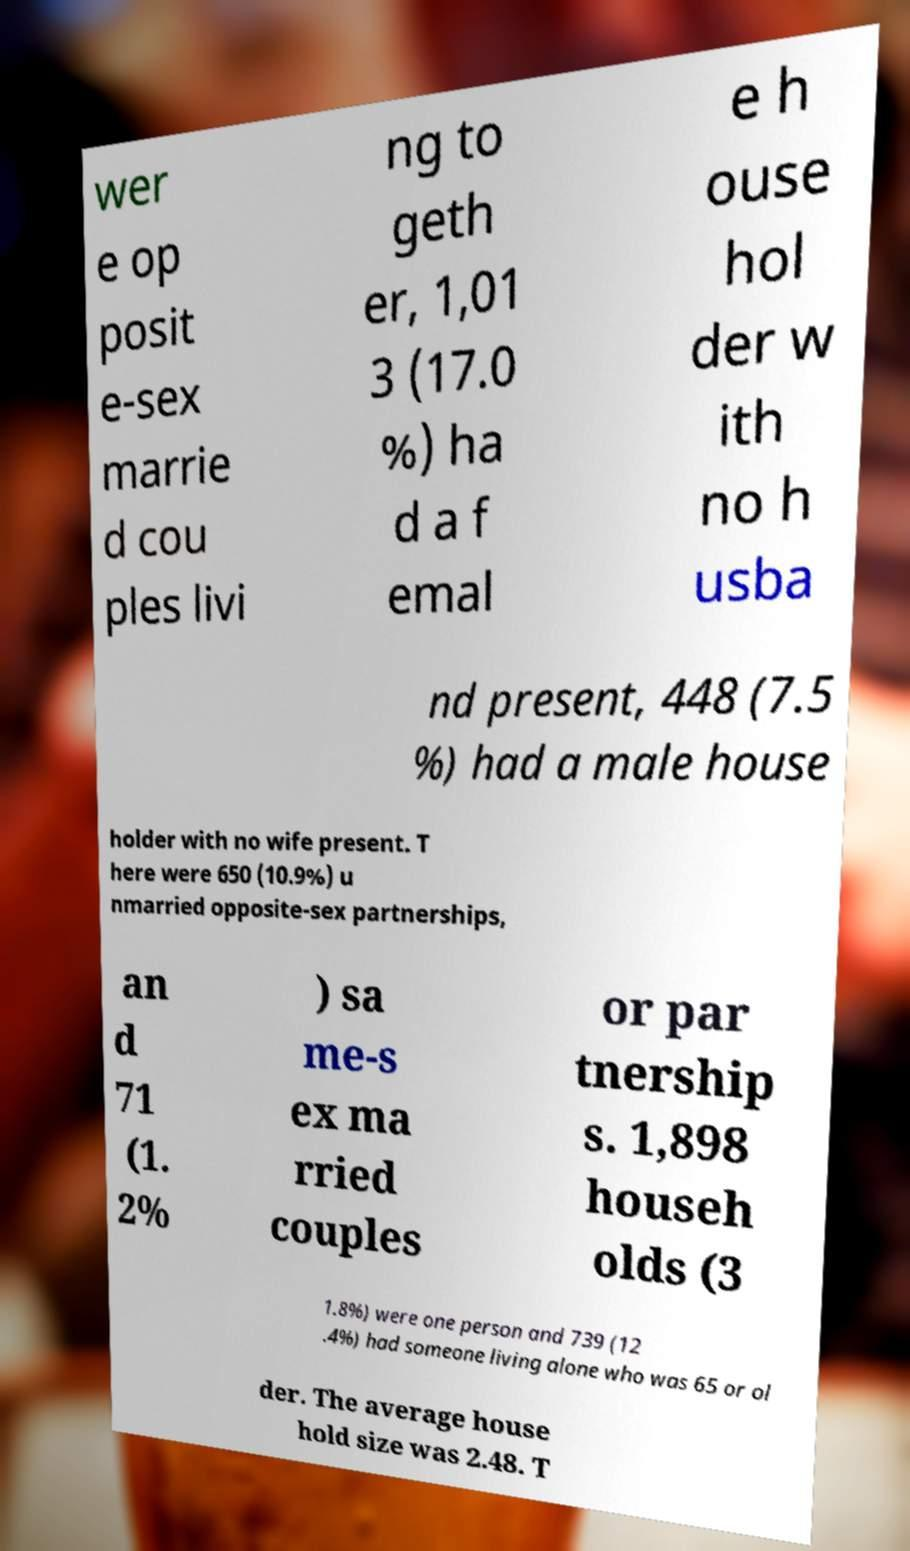For documentation purposes, I need the text within this image transcribed. Could you provide that? wer e op posit e-sex marrie d cou ples livi ng to geth er, 1,01 3 (17.0 %) ha d a f emal e h ouse hol der w ith no h usba nd present, 448 (7.5 %) had a male house holder with no wife present. T here were 650 (10.9%) u nmarried opposite-sex partnerships, an d 71 (1. 2% ) sa me-s ex ma rried couples or par tnership s. 1,898 househ olds (3 1.8%) were one person and 739 (12 .4%) had someone living alone who was 65 or ol der. The average house hold size was 2.48. T 